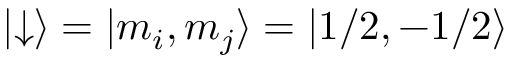Convert formula to latex. <formula><loc_0><loc_0><loc_500><loc_500>| { \downarrow } \rangle = | { m _ { i } , m _ { j } } \rangle = | { 1 / 2 , - 1 / 2 } \rangle</formula> 